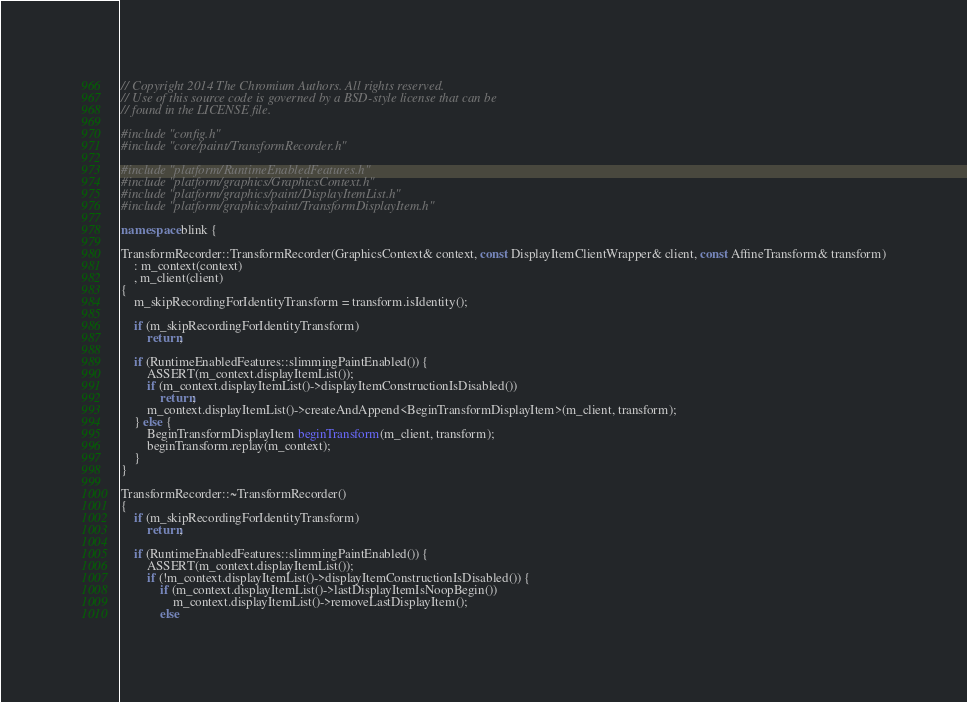Convert code to text. <code><loc_0><loc_0><loc_500><loc_500><_C++_>// Copyright 2014 The Chromium Authors. All rights reserved.
// Use of this source code is governed by a BSD-style license that can be
// found in the LICENSE file.

#include "config.h"
#include "core/paint/TransformRecorder.h"

#include "platform/RuntimeEnabledFeatures.h"
#include "platform/graphics/GraphicsContext.h"
#include "platform/graphics/paint/DisplayItemList.h"
#include "platform/graphics/paint/TransformDisplayItem.h"

namespace blink {

TransformRecorder::TransformRecorder(GraphicsContext& context, const DisplayItemClientWrapper& client, const AffineTransform& transform)
    : m_context(context)
    , m_client(client)
{
    m_skipRecordingForIdentityTransform = transform.isIdentity();

    if (m_skipRecordingForIdentityTransform)
        return;

    if (RuntimeEnabledFeatures::slimmingPaintEnabled()) {
        ASSERT(m_context.displayItemList());
        if (m_context.displayItemList()->displayItemConstructionIsDisabled())
            return;
        m_context.displayItemList()->createAndAppend<BeginTransformDisplayItem>(m_client, transform);
    } else {
        BeginTransformDisplayItem beginTransform(m_client, transform);
        beginTransform.replay(m_context);
    }
}

TransformRecorder::~TransformRecorder()
{
    if (m_skipRecordingForIdentityTransform)
        return;

    if (RuntimeEnabledFeatures::slimmingPaintEnabled()) {
        ASSERT(m_context.displayItemList());
        if (!m_context.displayItemList()->displayItemConstructionIsDisabled()) {
            if (m_context.displayItemList()->lastDisplayItemIsNoopBegin())
                m_context.displayItemList()->removeLastDisplayItem();
            else</code> 